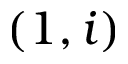<formula> <loc_0><loc_0><loc_500><loc_500>( 1 , i )</formula> 